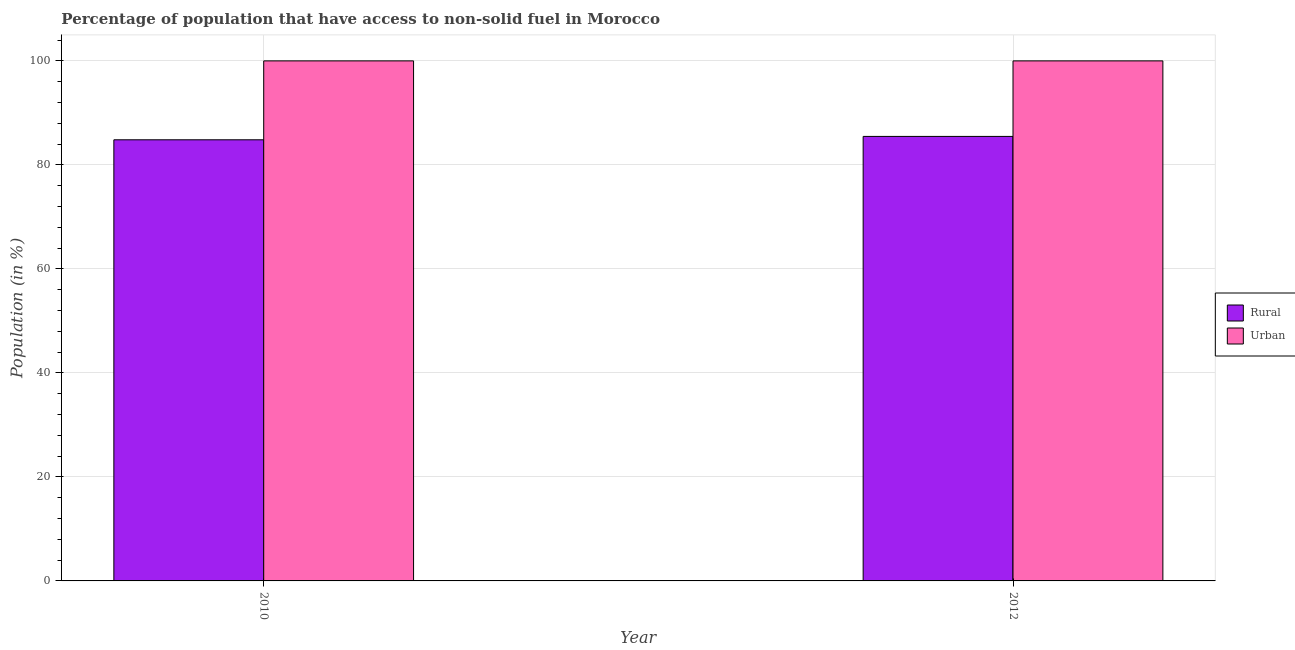How many bars are there on the 2nd tick from the right?
Provide a short and direct response. 2. In how many cases, is the number of bars for a given year not equal to the number of legend labels?
Give a very brief answer. 0. What is the urban population in 2012?
Offer a terse response. 100. Across all years, what is the maximum rural population?
Provide a short and direct response. 85.48. Across all years, what is the minimum rural population?
Offer a terse response. 84.82. In which year was the rural population maximum?
Offer a terse response. 2012. What is the total urban population in the graph?
Ensure brevity in your answer.  200. What is the average rural population per year?
Ensure brevity in your answer.  85.15. In the year 2012, what is the difference between the urban population and rural population?
Provide a short and direct response. 0. In how many years, is the rural population greater than 44 %?
Give a very brief answer. 2. What is the ratio of the rural population in 2010 to that in 2012?
Ensure brevity in your answer.  0.99. What does the 2nd bar from the left in 2010 represents?
Provide a succinct answer. Urban. What does the 2nd bar from the right in 2010 represents?
Provide a succinct answer. Rural. How many bars are there?
Make the answer very short. 4. How many years are there in the graph?
Your answer should be compact. 2. What is the difference between two consecutive major ticks on the Y-axis?
Your response must be concise. 20. Does the graph contain grids?
Provide a short and direct response. Yes. Where does the legend appear in the graph?
Your answer should be compact. Center right. How are the legend labels stacked?
Keep it short and to the point. Vertical. What is the title of the graph?
Your response must be concise. Percentage of population that have access to non-solid fuel in Morocco. What is the Population (in %) of Rural in 2010?
Make the answer very short. 84.82. What is the Population (in %) in Rural in 2012?
Keep it short and to the point. 85.48. Across all years, what is the maximum Population (in %) of Rural?
Your response must be concise. 85.48. Across all years, what is the maximum Population (in %) of Urban?
Provide a succinct answer. 100. Across all years, what is the minimum Population (in %) of Rural?
Give a very brief answer. 84.82. What is the total Population (in %) of Rural in the graph?
Offer a very short reply. 170.3. What is the total Population (in %) in Urban in the graph?
Your answer should be very brief. 200. What is the difference between the Population (in %) in Rural in 2010 and that in 2012?
Make the answer very short. -0.65. What is the difference between the Population (in %) in Urban in 2010 and that in 2012?
Make the answer very short. 0. What is the difference between the Population (in %) in Rural in 2010 and the Population (in %) in Urban in 2012?
Your response must be concise. -15.18. What is the average Population (in %) in Rural per year?
Provide a succinct answer. 85.15. What is the average Population (in %) in Urban per year?
Your response must be concise. 100. In the year 2010, what is the difference between the Population (in %) in Rural and Population (in %) in Urban?
Offer a very short reply. -15.18. In the year 2012, what is the difference between the Population (in %) in Rural and Population (in %) in Urban?
Provide a short and direct response. -14.52. What is the ratio of the Population (in %) in Rural in 2010 to that in 2012?
Make the answer very short. 0.99. What is the difference between the highest and the second highest Population (in %) of Rural?
Your answer should be compact. 0.65. What is the difference between the highest and the lowest Population (in %) in Rural?
Offer a very short reply. 0.65. 